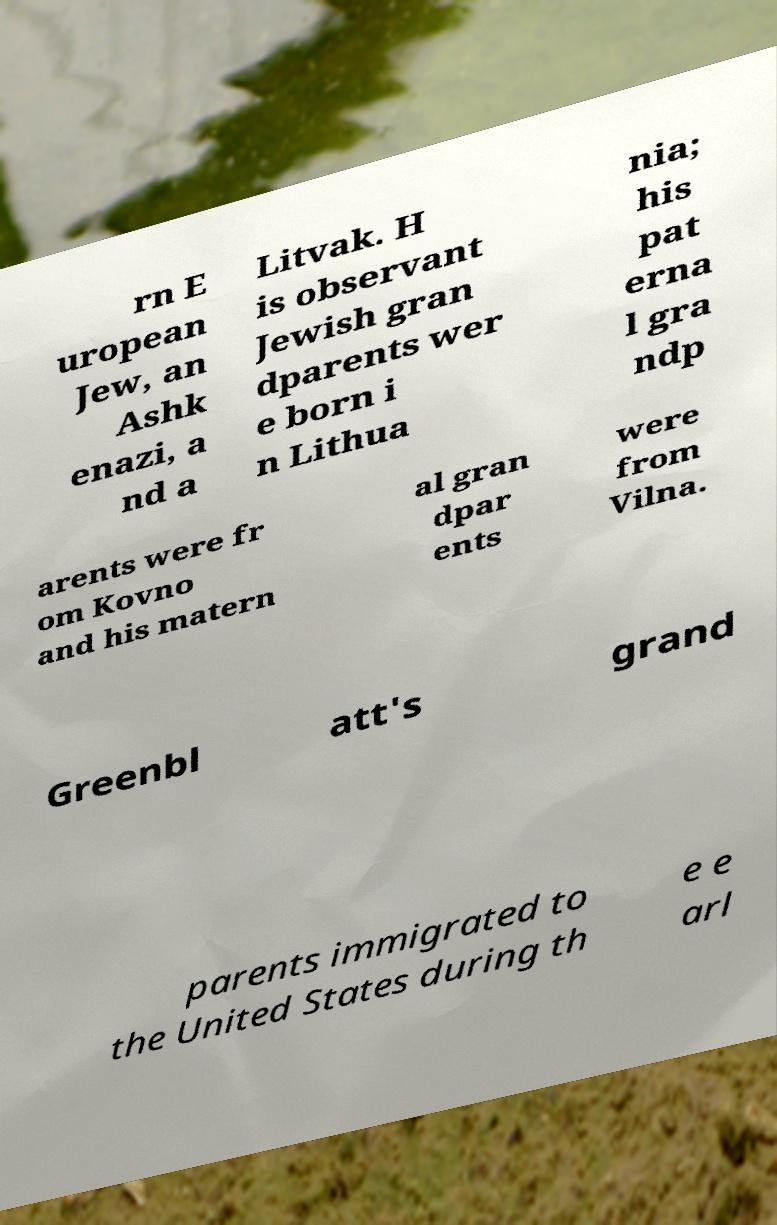Could you extract and type out the text from this image? rn E uropean Jew, an Ashk enazi, a nd a Litvak. H is observant Jewish gran dparents wer e born i n Lithua nia; his pat erna l gra ndp arents were fr om Kovno and his matern al gran dpar ents were from Vilna. Greenbl att's grand parents immigrated to the United States during th e e arl 